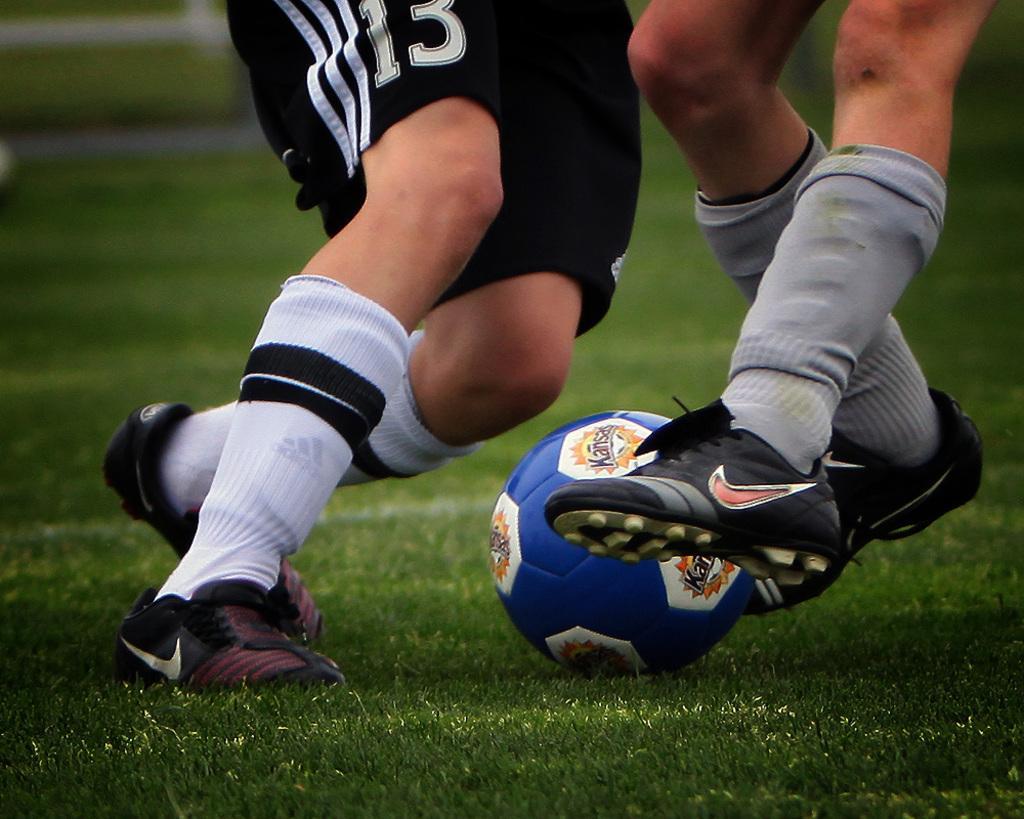Describe this image in one or two sentences. In the image we can see legs of two persons wearing shorts, socks and shoes. Here we can see the ball and grass. 